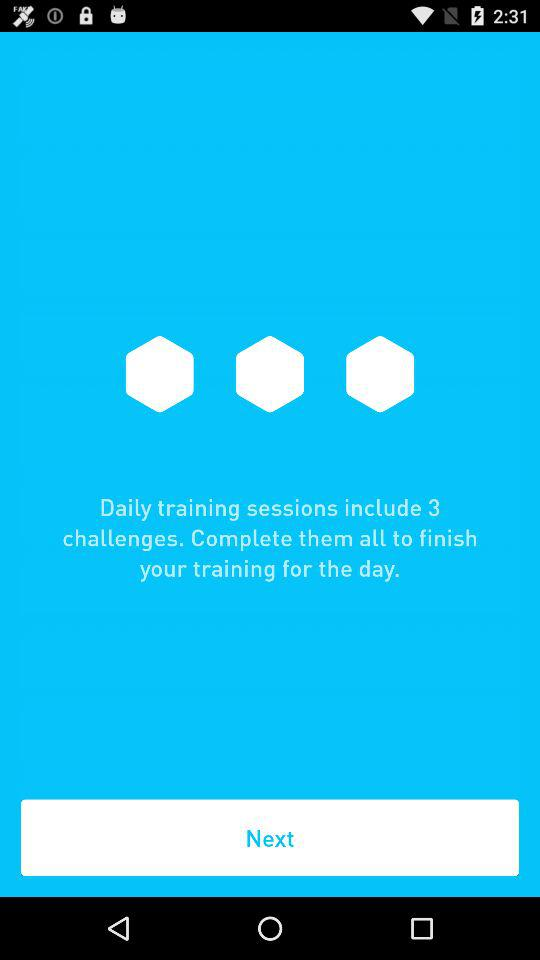How many challenges do you have to complete to finish your training for the day?
Answer the question using a single word or phrase. 3 